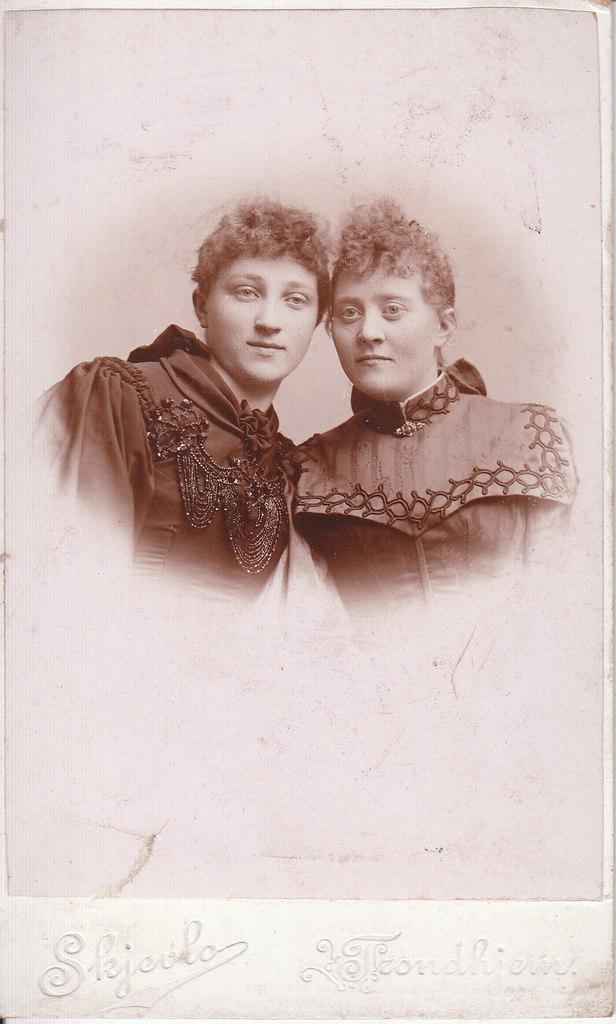In one or two sentences, can you explain what this image depicts? In this image we can see picture of two persons. At the bottom of the image we can see text written on it. 